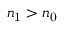<formula> <loc_0><loc_0><loc_500><loc_500>n _ { 1 } > n _ { 0 }</formula> 